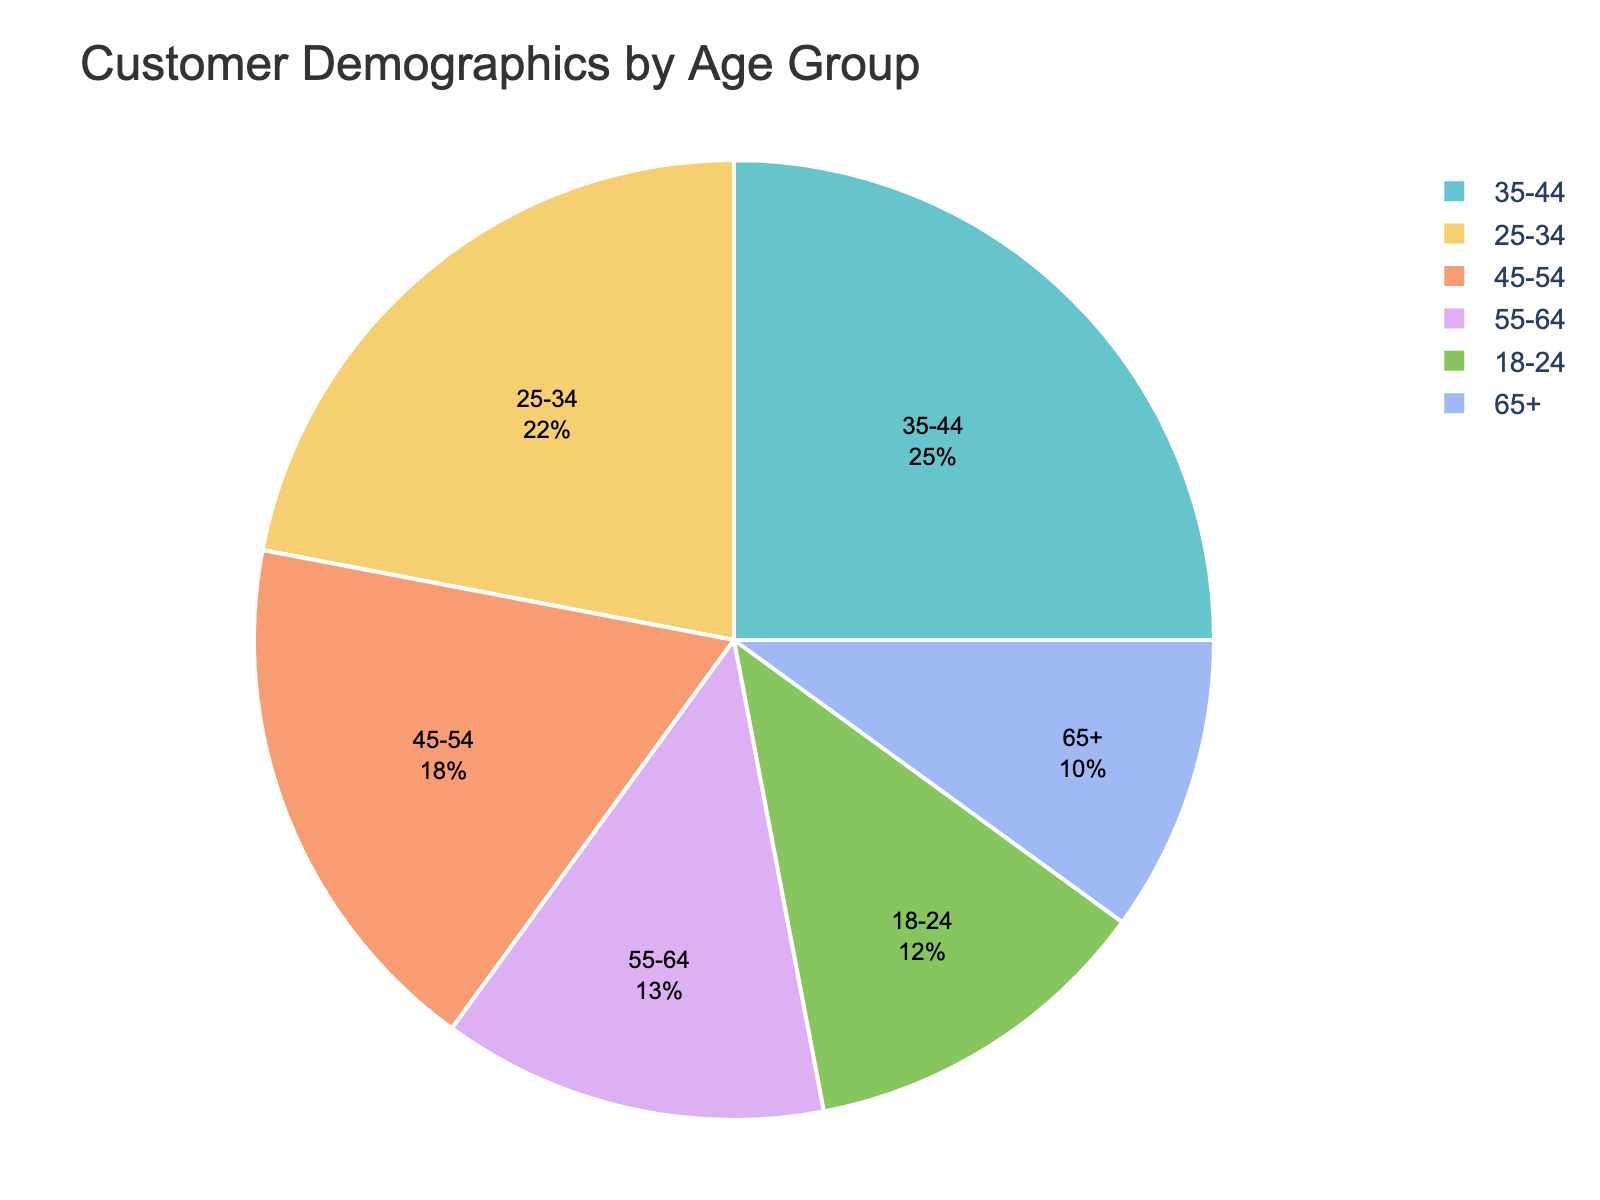What is the age group with the highest customer percentage? Observe the size of the slices in the pie chart and locate the largest one. The 35-44 age group has the largest slice, indicating it has the highest percentage.
Answer: 35-44 Which two age groups have a combined percentage of over 40%? Add the percentages of different age groups and identify combinations that exceed 40%. The 25-34 and 35-44 age groups have percentages of 22% and 25% respectively, totaling 47%.
Answer: 25-34 and 35-44 What is the difference in percentage between the 45-54 and 65+ age groups? Subtract the percentage of the 65+ age group from that of the 45-54 age group (18% - 10%).
Answer: 8% Which age group has a percentage closest to the average customer percentage across all age groups? Calculate the average percentage: (12% + 22% + 25% + 18% + 13% + 10%) / 6 = 16.67%. The 45-54 age group at 18% is nearest to this average.
Answer: 45-54 What is the combined percentage of the three youngest age groups? Add the percentages of the 18-24, 25-34, and 35-44 age groups: 12% + 22% + 25% = 59%.
Answer: 59% Which age group has the smallest percentage of customers? Identify the smallest slice in the pie chart, which corresponds to the 65+ age group at 10%.
Answer: 65+ Is the percentage of customers aged 55-64 greater or lesser than that of customers aged 18-24? Compare the percentages of the 55-64 and 18-24 age groups; 13% for 55-64 is greater than 12% for 18-24.
Answer: Greater What is the sum of the percentages for customers aged 35-44 and those aged 55-64? Add the percentages of the 35-44 and 55-64 age groups: 25% + 13% = 38%.
Answer: 38% How many age groups have a customer percentage greater than 15%? Identify and count the age groups with percentages above 15%: 25-34, 35-44, and 45-54, totaling three age groups.
Answer: 3 